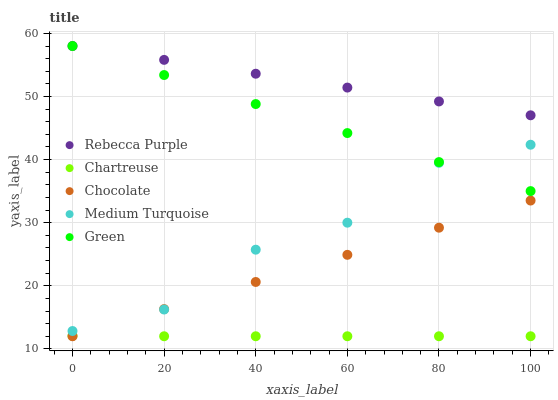Does Chartreuse have the minimum area under the curve?
Answer yes or no. Yes. Does Rebecca Purple have the maximum area under the curve?
Answer yes or no. Yes. Does Green have the minimum area under the curve?
Answer yes or no. No. Does Green have the maximum area under the curve?
Answer yes or no. No. Is Chocolate the smoothest?
Answer yes or no. Yes. Is Medium Turquoise the roughest?
Answer yes or no. Yes. Is Green the smoothest?
Answer yes or no. No. Is Green the roughest?
Answer yes or no. No. Does Chartreuse have the lowest value?
Answer yes or no. Yes. Does Green have the lowest value?
Answer yes or no. No. Does Rebecca Purple have the highest value?
Answer yes or no. Yes. Does Medium Turquoise have the highest value?
Answer yes or no. No. Is Chocolate less than Rebecca Purple?
Answer yes or no. Yes. Is Rebecca Purple greater than Chocolate?
Answer yes or no. Yes. Does Medium Turquoise intersect Chocolate?
Answer yes or no. Yes. Is Medium Turquoise less than Chocolate?
Answer yes or no. No. Is Medium Turquoise greater than Chocolate?
Answer yes or no. No. Does Chocolate intersect Rebecca Purple?
Answer yes or no. No. 